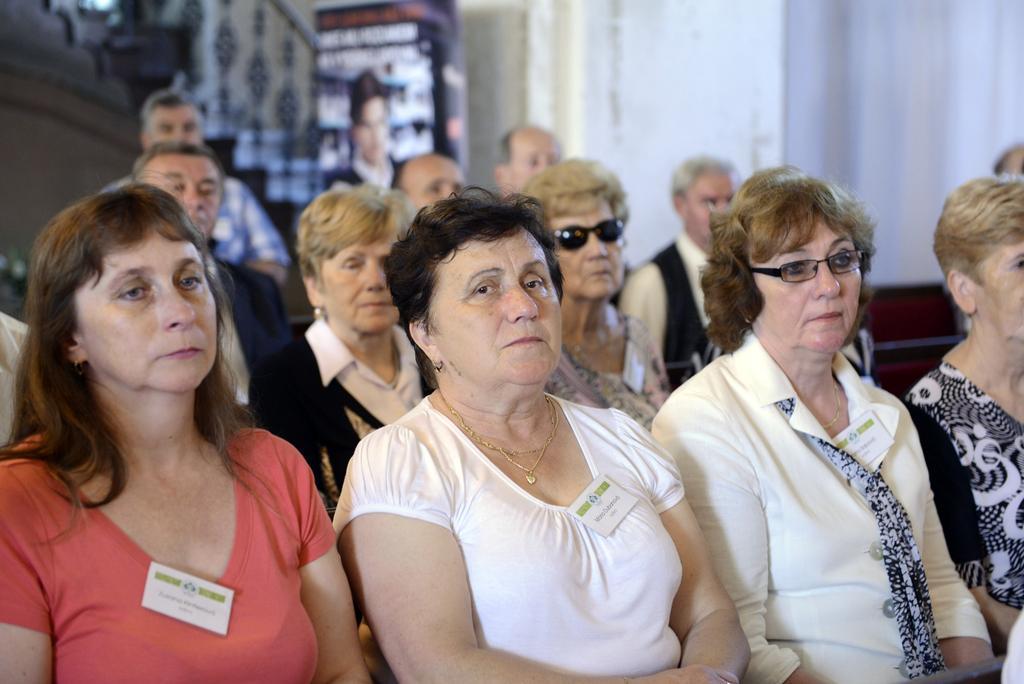Describe this image in one or two sentences. Here in this picture we can see a group of old men and women sitting on chairs over there and we can see all of them are having name cards on them and some people are wearing spectacles and goggles on them over there. 